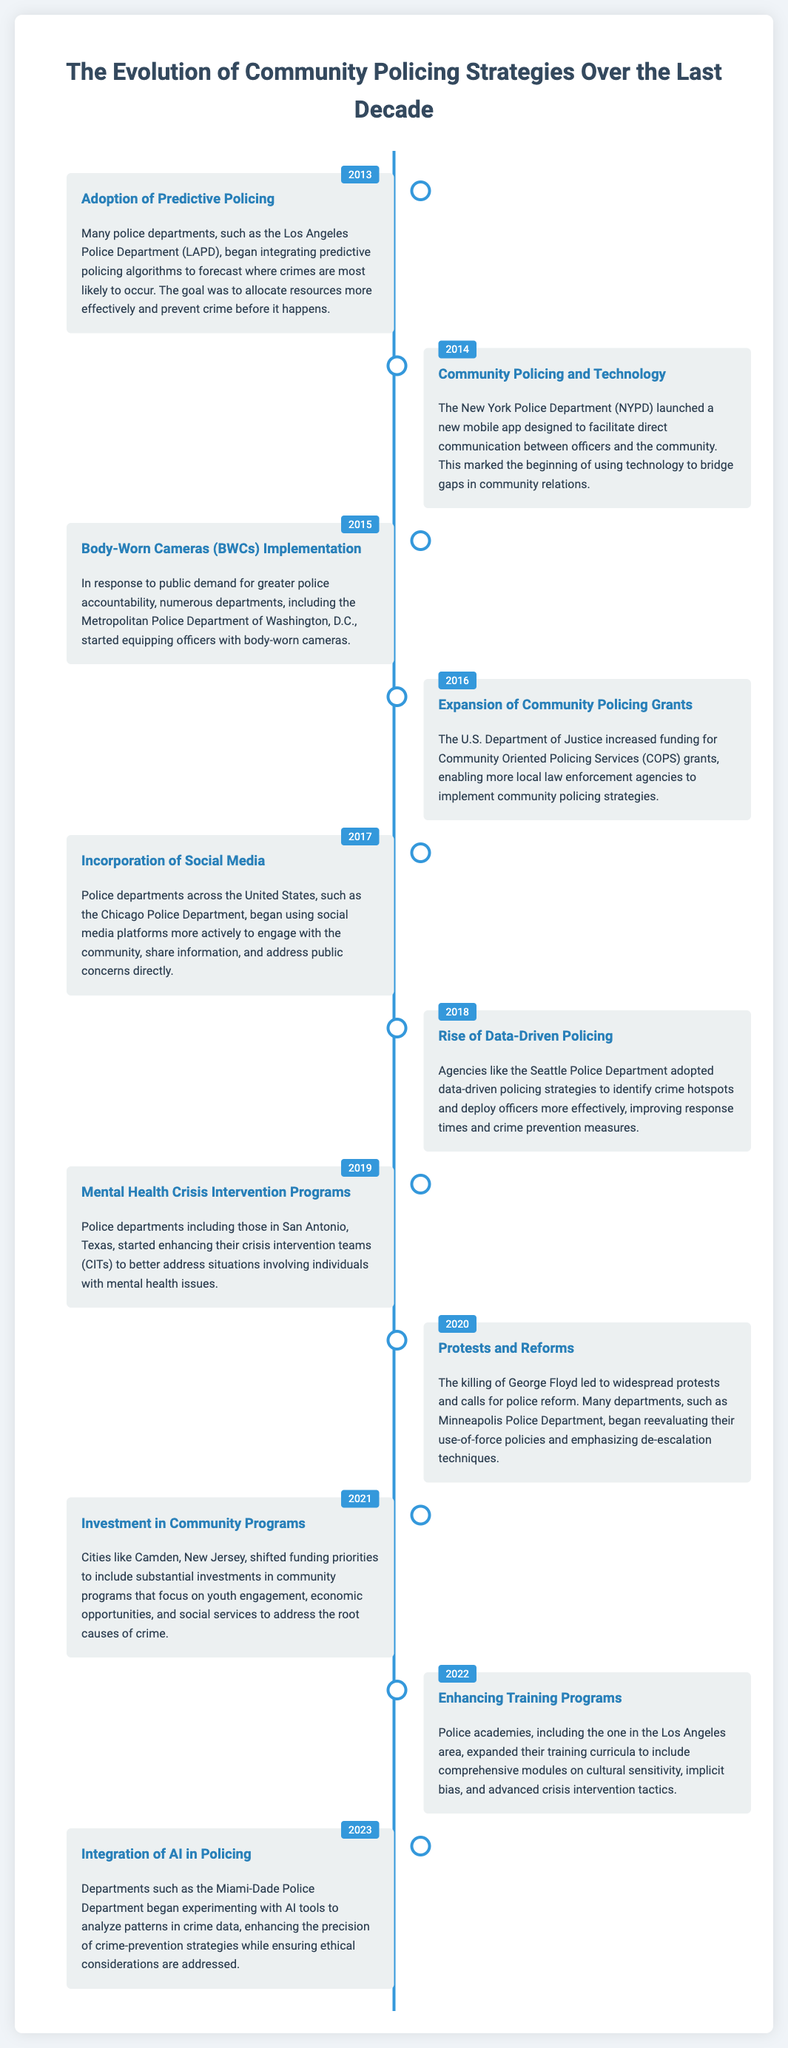What year did departments begin adopting predictive policing? The document states that many police departments began integrating predictive policing algorithms in 2013.
Answer: 2013 What technology was launched by NYPD in 2014? The New York Police Department launched a mobile app designed to facilitate direct communication between officers and the community in 2014.
Answer: Mobile app Which department implemented Body-Worn Cameras in 2015? The Metropolitan Police Department of Washington, D.C., started equipping officers with body-worn cameras in 2015.
Answer: Metropolitan Police Department In what year did the U.S. Department of Justice increase funding for community policing grants? The increase in funding for Community Oriented Policing Services (COPS) grants occurred in 2016.
Answer: 2016 What significant event led to calls for police reform in 2020? The killing of George Floyd led to widespread protests and calls for police reform in 2020.
Answer: Killing of George Floyd What was a major focus of community funding changes in Camden, New Jersey, in 2021? In 2021, Camden focused on substantial investments in community programs that address the root causes of crime, including youth engagement.
Answer: Youth engagement What did police academies enhance in their training programs in 2022? Police academies expanded their training curricula in 2022 to include comprehensive modules on cultural sensitivity.
Answer: Cultural sensitivity Which police department began integrating AI tools in 2023? The Miami-Dade Police Department started experimenting with AI tools to analyze patterns in crime data in 2023.
Answer: Miami-Dade Police Department What policing strategy rose in popularity in 2018? Data-driven policing strategies were adopted by agencies like the Seattle Police Department in 2018.
Answer: Data-driven policing 